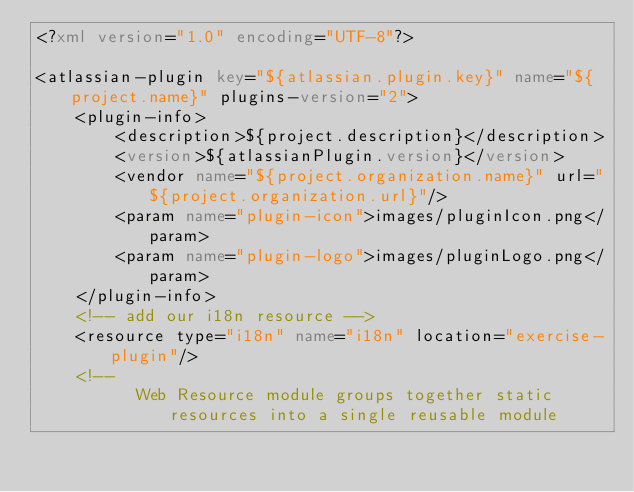<code> <loc_0><loc_0><loc_500><loc_500><_XML_><?xml version="1.0" encoding="UTF-8"?>

<atlassian-plugin key="${atlassian.plugin.key}" name="${project.name}" plugins-version="2">
    <plugin-info>
        <description>${project.description}</description>
        <version>${atlassianPlugin.version}</version>
        <vendor name="${project.organization.name}" url="${project.organization.url}"/>
        <param name="plugin-icon">images/pluginIcon.png</param>
        <param name="plugin-logo">images/pluginLogo.png</param>
    </plugin-info>
    <!-- add our i18n resource -->
    <resource type="i18n" name="i18n" location="exercise-plugin"/>
    <!--
          Web Resource module groups together static resources into a single reusable module</code> 